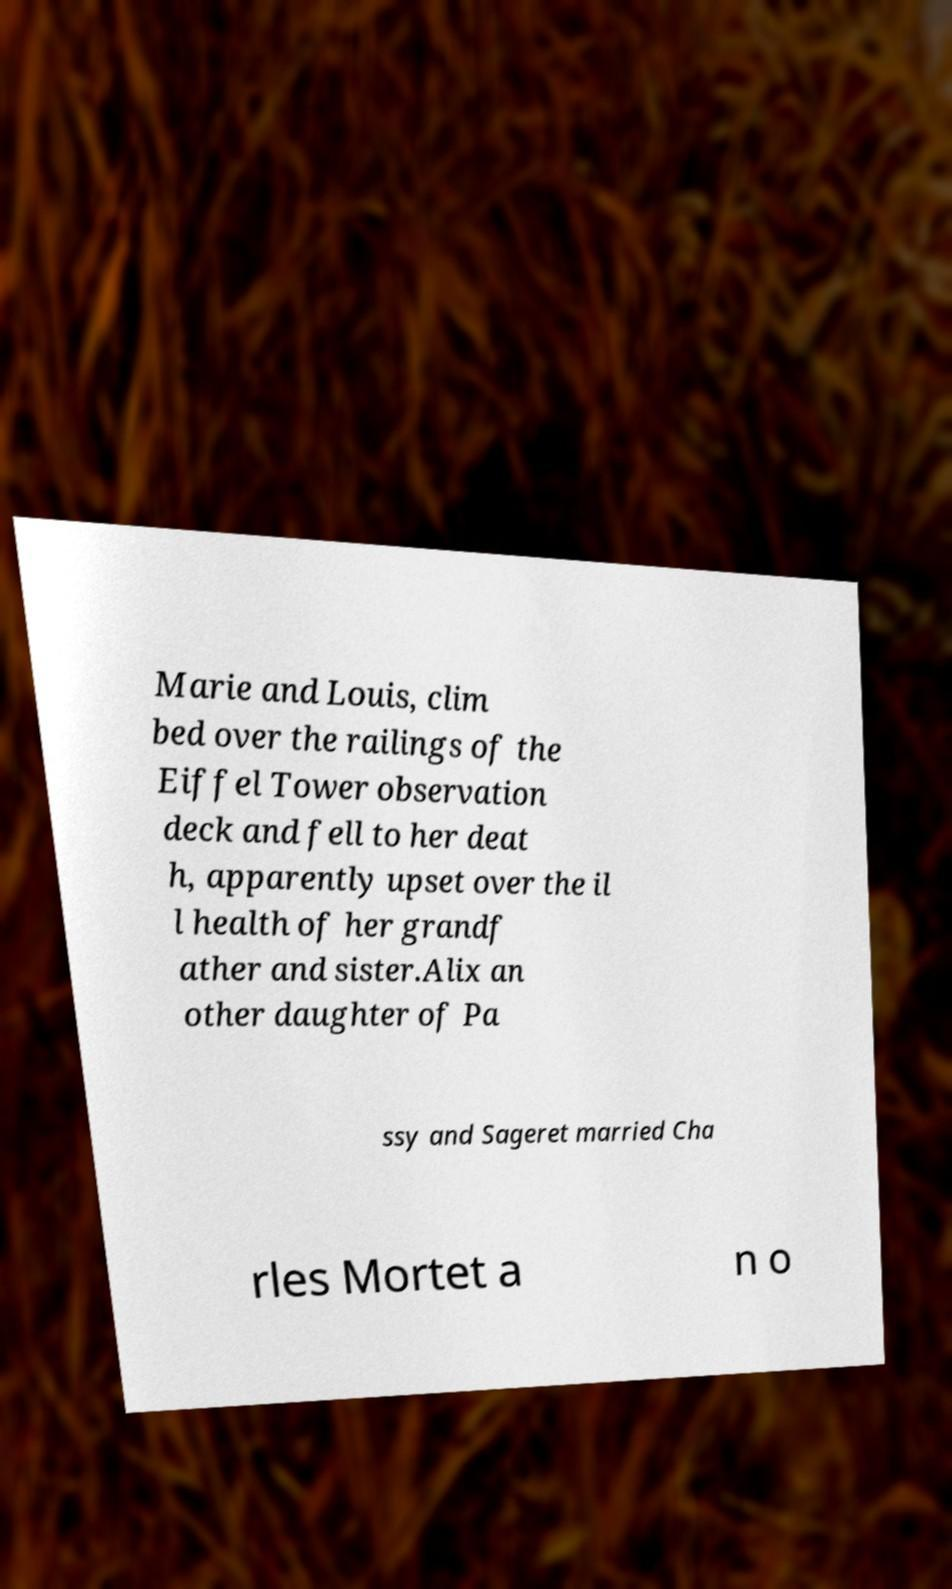Please identify and transcribe the text found in this image. Marie and Louis, clim bed over the railings of the Eiffel Tower observation deck and fell to her deat h, apparently upset over the il l health of her grandf ather and sister.Alix an other daughter of Pa ssy and Sageret married Cha rles Mortet a n o 